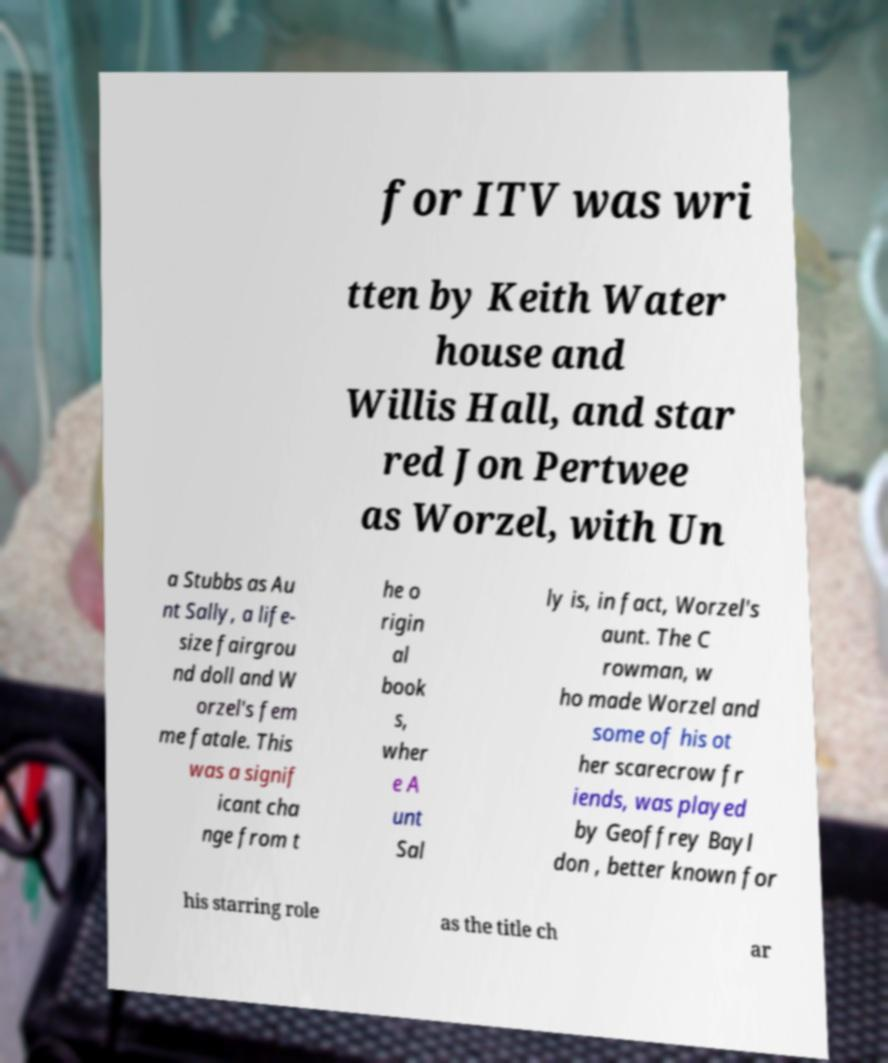Could you extract and type out the text from this image? for ITV was wri tten by Keith Water house and Willis Hall, and star red Jon Pertwee as Worzel, with Un a Stubbs as Au nt Sally, a life- size fairgrou nd doll and W orzel's fem me fatale. This was a signif icant cha nge from t he o rigin al book s, wher e A unt Sal ly is, in fact, Worzel's aunt. The C rowman, w ho made Worzel and some of his ot her scarecrow fr iends, was played by Geoffrey Bayl don , better known for his starring role as the title ch ar 